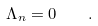Convert formula to latex. <formula><loc_0><loc_0><loc_500><loc_500>\Lambda _ { n } = 0 \quad .</formula> 